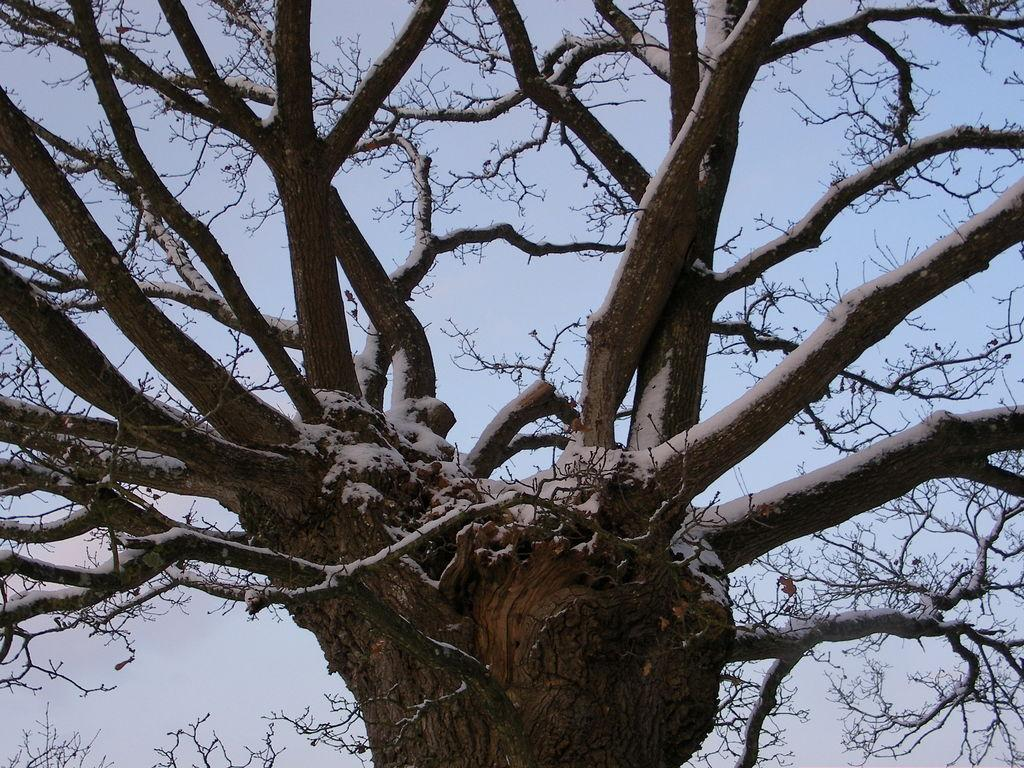What is present in the image? There is a tree in the image. Can you describe the tree's appearance? The tree is without leaves. What type of cable can be seen hanging from the tree in the image? There is no cable present in the image; it only features a tree without leaves. 